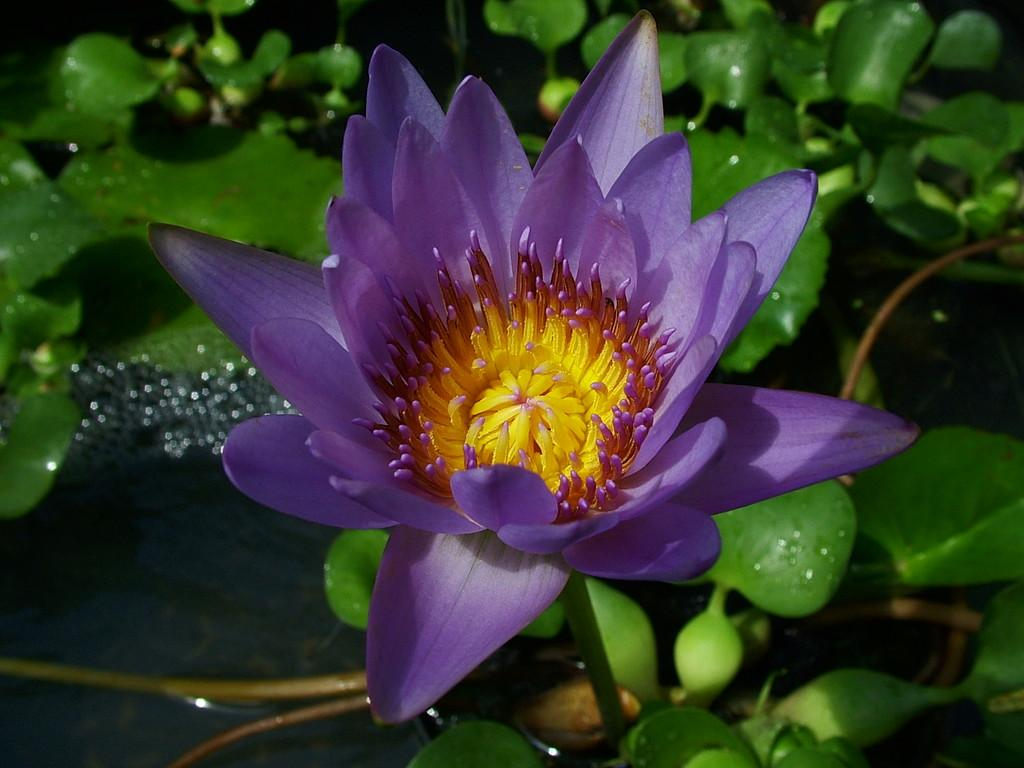What is the main subject of the image? There is a flower in the image. What can be seen in the background of the image? There is water and plants visible in the background of the image. How many eyes can be seen on the flower in the image? Flowers do not have eyes, so there are no eyes visible on the flower in the image. 